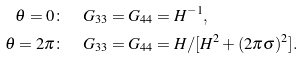Convert formula to latex. <formula><loc_0><loc_0><loc_500><loc_500>\theta = 0 & \colon \quad G _ { 3 3 } = G _ { 4 4 } = H ^ { - 1 } , \\ \theta = 2 \pi & \colon \quad G _ { 3 3 } = G _ { 4 4 } = { H / [ H ^ { 2 } + ( 2 \pi \sigma ) ^ { 2 } ] } .</formula> 